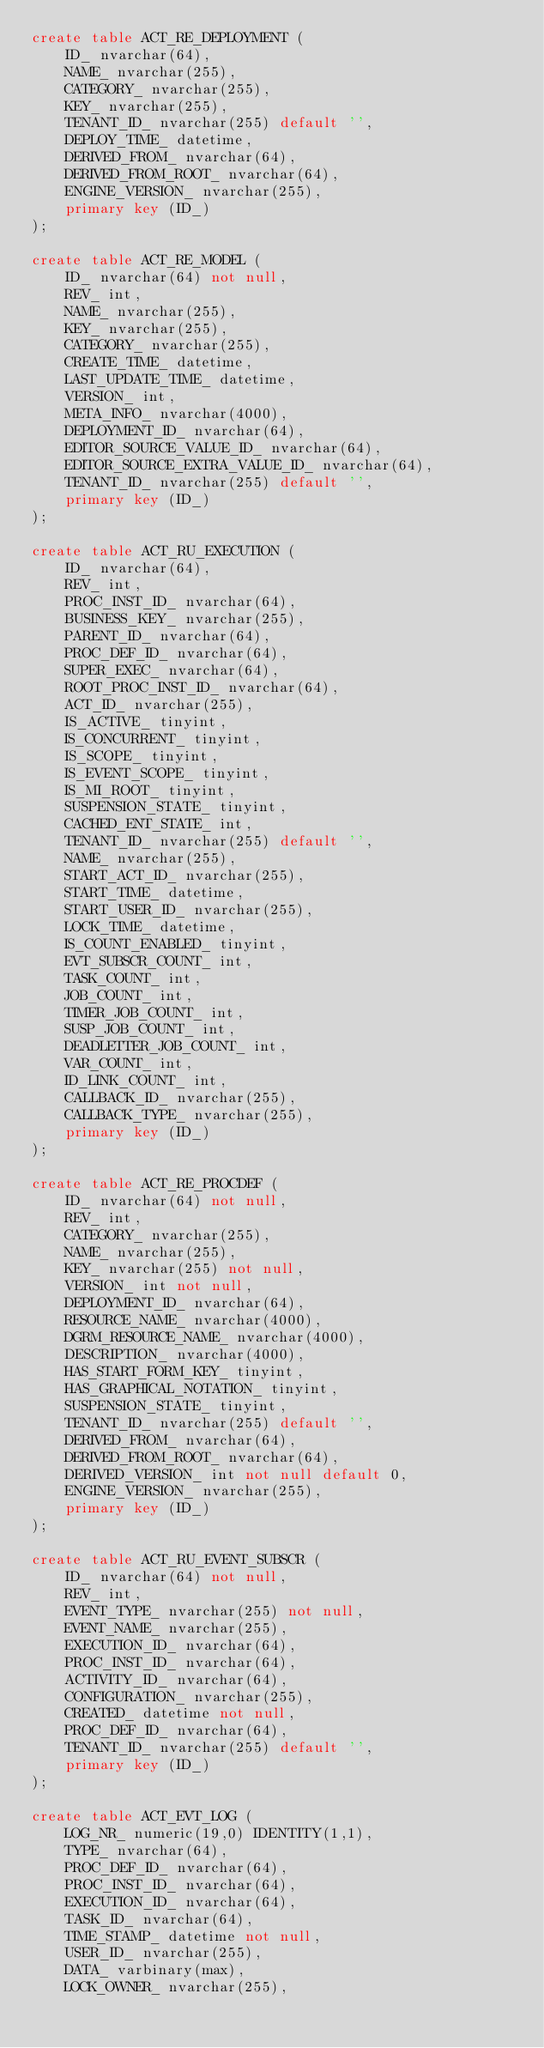Convert code to text. <code><loc_0><loc_0><loc_500><loc_500><_SQL_>create table ACT_RE_DEPLOYMENT (
    ID_ nvarchar(64),
    NAME_ nvarchar(255),
    CATEGORY_ nvarchar(255),
    KEY_ nvarchar(255),
    TENANT_ID_ nvarchar(255) default '',
    DEPLOY_TIME_ datetime,
    DERIVED_FROM_ nvarchar(64),
    DERIVED_FROM_ROOT_ nvarchar(64),
    ENGINE_VERSION_ nvarchar(255),
    primary key (ID_)
);

create table ACT_RE_MODEL (
    ID_ nvarchar(64) not null,
    REV_ int,
    NAME_ nvarchar(255),
    KEY_ nvarchar(255),
    CATEGORY_ nvarchar(255),
    CREATE_TIME_ datetime,
    LAST_UPDATE_TIME_ datetime,
    VERSION_ int,
    META_INFO_ nvarchar(4000),
    DEPLOYMENT_ID_ nvarchar(64),
    EDITOR_SOURCE_VALUE_ID_ nvarchar(64),
    EDITOR_SOURCE_EXTRA_VALUE_ID_ nvarchar(64),
    TENANT_ID_ nvarchar(255) default '',
    primary key (ID_)
);

create table ACT_RU_EXECUTION (
    ID_ nvarchar(64),
    REV_ int,
    PROC_INST_ID_ nvarchar(64),
    BUSINESS_KEY_ nvarchar(255),
    PARENT_ID_ nvarchar(64),
    PROC_DEF_ID_ nvarchar(64),
    SUPER_EXEC_ nvarchar(64),
    ROOT_PROC_INST_ID_ nvarchar(64),
    ACT_ID_ nvarchar(255),
    IS_ACTIVE_ tinyint,
    IS_CONCURRENT_ tinyint,
    IS_SCOPE_ tinyint,
    IS_EVENT_SCOPE_ tinyint,
    IS_MI_ROOT_ tinyint,
    SUSPENSION_STATE_ tinyint,
    CACHED_ENT_STATE_ int,
    TENANT_ID_ nvarchar(255) default '',
    NAME_ nvarchar(255),
    START_ACT_ID_ nvarchar(255),
    START_TIME_ datetime,
    START_USER_ID_ nvarchar(255),
    LOCK_TIME_ datetime,
    IS_COUNT_ENABLED_ tinyint,
    EVT_SUBSCR_COUNT_ int, 
    TASK_COUNT_ int, 
    JOB_COUNT_ int, 
    TIMER_JOB_COUNT_ int,
    SUSP_JOB_COUNT_ int,
    DEADLETTER_JOB_COUNT_ int,
    VAR_COUNT_ int, 
    ID_LINK_COUNT_ int,
    CALLBACK_ID_ nvarchar(255),
    CALLBACK_TYPE_ nvarchar(255),
    primary key (ID_)
);

create table ACT_RE_PROCDEF (
    ID_ nvarchar(64) not null,
    REV_ int,
    CATEGORY_ nvarchar(255),
    NAME_ nvarchar(255),
    KEY_ nvarchar(255) not null,
    VERSION_ int not null,
    DEPLOYMENT_ID_ nvarchar(64),
    RESOURCE_NAME_ nvarchar(4000),
    DGRM_RESOURCE_NAME_ nvarchar(4000),
    DESCRIPTION_ nvarchar(4000),
    HAS_START_FORM_KEY_ tinyint,
    HAS_GRAPHICAL_NOTATION_ tinyint,
    SUSPENSION_STATE_ tinyint,
    TENANT_ID_ nvarchar(255) default '',
    DERIVED_FROM_ nvarchar(64),
    DERIVED_FROM_ROOT_ nvarchar(64),
    DERIVED_VERSION_ int not null default 0,
    ENGINE_VERSION_ nvarchar(255),
    primary key (ID_)
);

create table ACT_RU_EVENT_SUBSCR (
    ID_ nvarchar(64) not null,
    REV_ int,
    EVENT_TYPE_ nvarchar(255) not null,
    EVENT_NAME_ nvarchar(255),
    EXECUTION_ID_ nvarchar(64),
    PROC_INST_ID_ nvarchar(64),
    ACTIVITY_ID_ nvarchar(64),
    CONFIGURATION_ nvarchar(255),
    CREATED_ datetime not null,
    PROC_DEF_ID_ nvarchar(64),
    TENANT_ID_ nvarchar(255) default '',
    primary key (ID_)
);

create table ACT_EVT_LOG (
    LOG_NR_ numeric(19,0) IDENTITY(1,1),
    TYPE_ nvarchar(64),
    PROC_DEF_ID_ nvarchar(64),
    PROC_INST_ID_ nvarchar(64),
    EXECUTION_ID_ nvarchar(64),
    TASK_ID_ nvarchar(64),
    TIME_STAMP_ datetime not null,
    USER_ID_ nvarchar(255),
    DATA_ varbinary(max),
    LOCK_OWNER_ nvarchar(255),</code> 